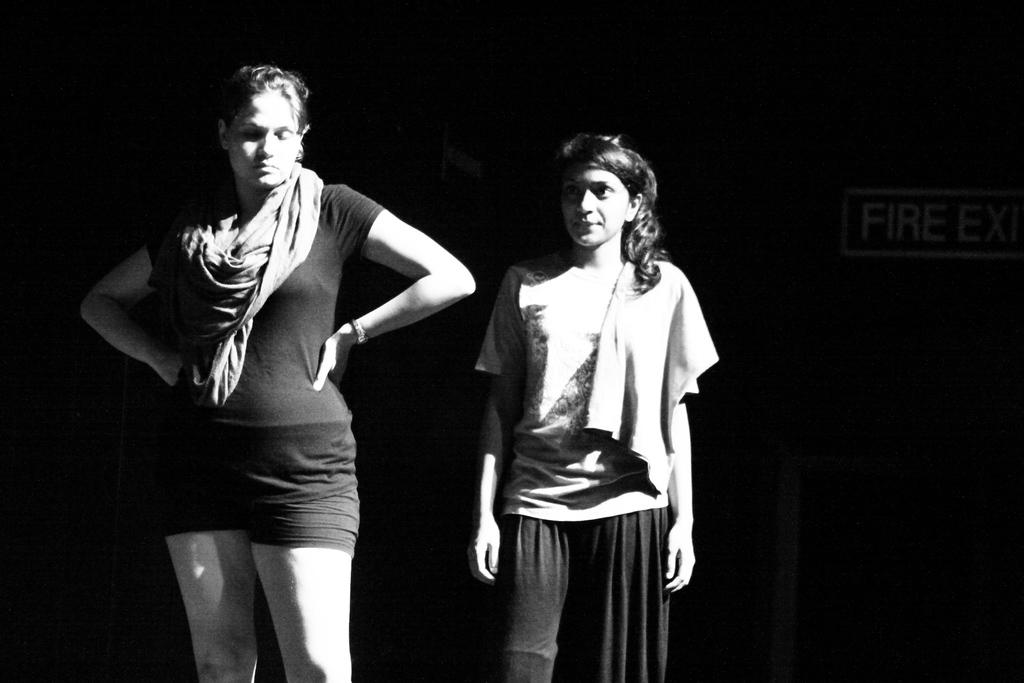What is the primary subject of the image? The primary subject of the image is women standing. Can you describe the setting of the image? In the background of the image, there is a door. What type of fiction is the women reading in the image? There is no indication in the image that the women are reading fiction or any other type of material. 